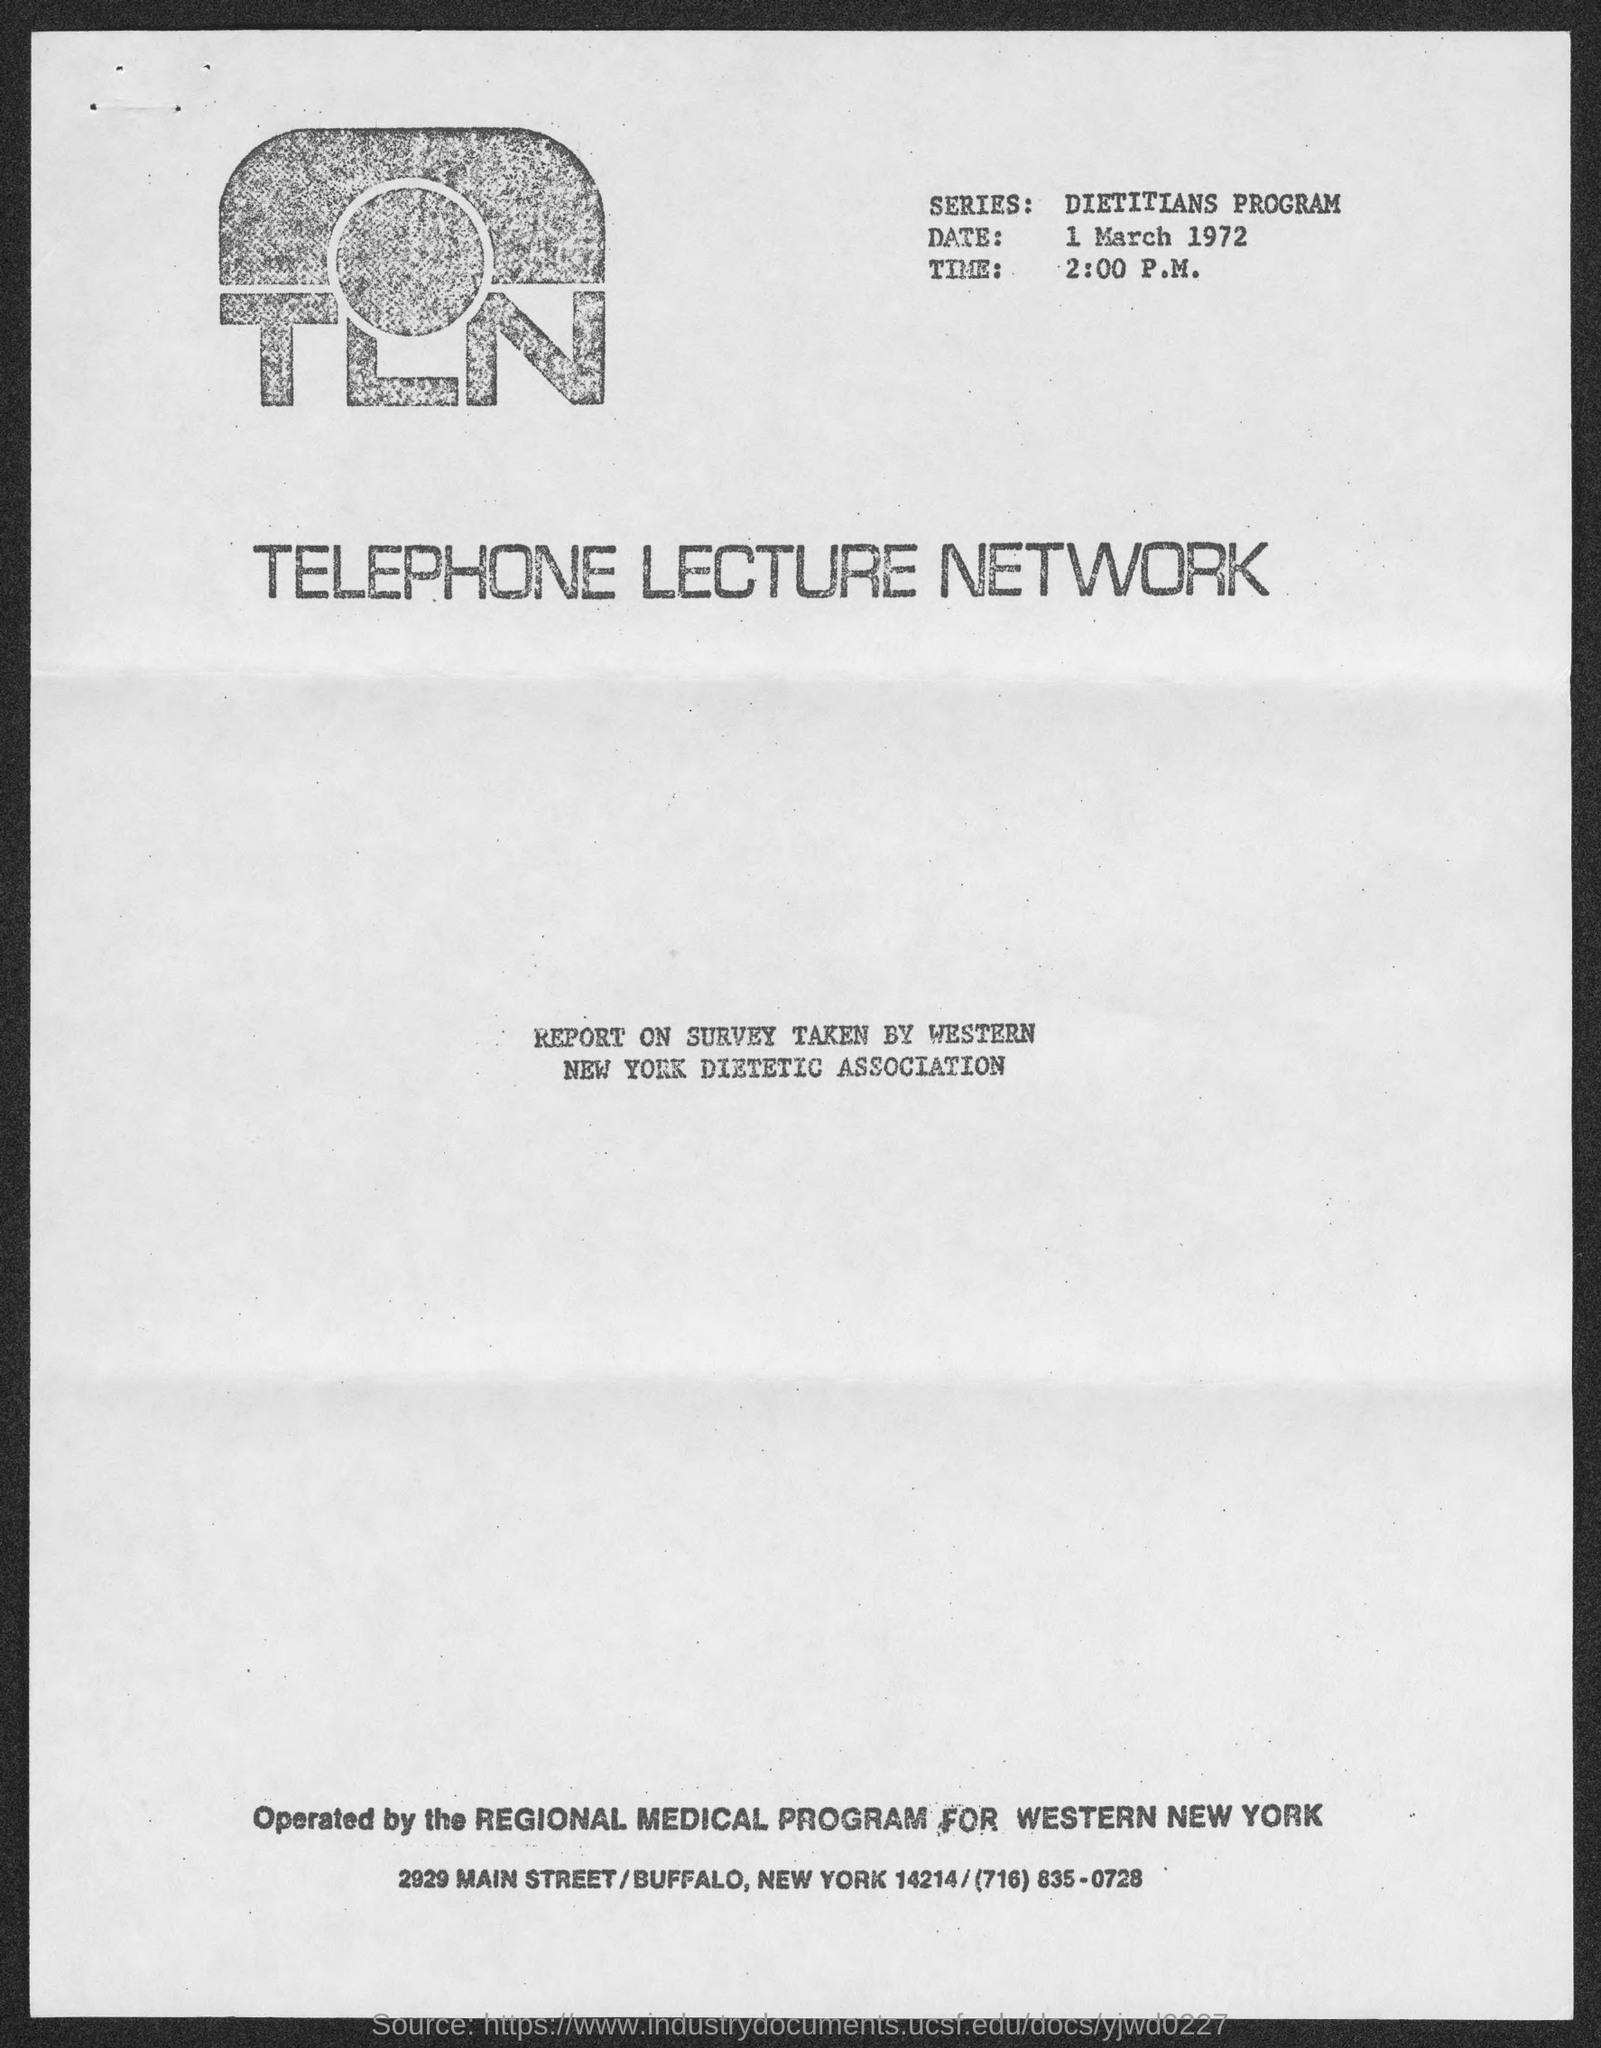List a handful of essential elements in this visual. The date at the top of the page is March 1, 1972. The series name is "Dietitians Program...". The time displayed beside the logo is 2:00 P.M. 